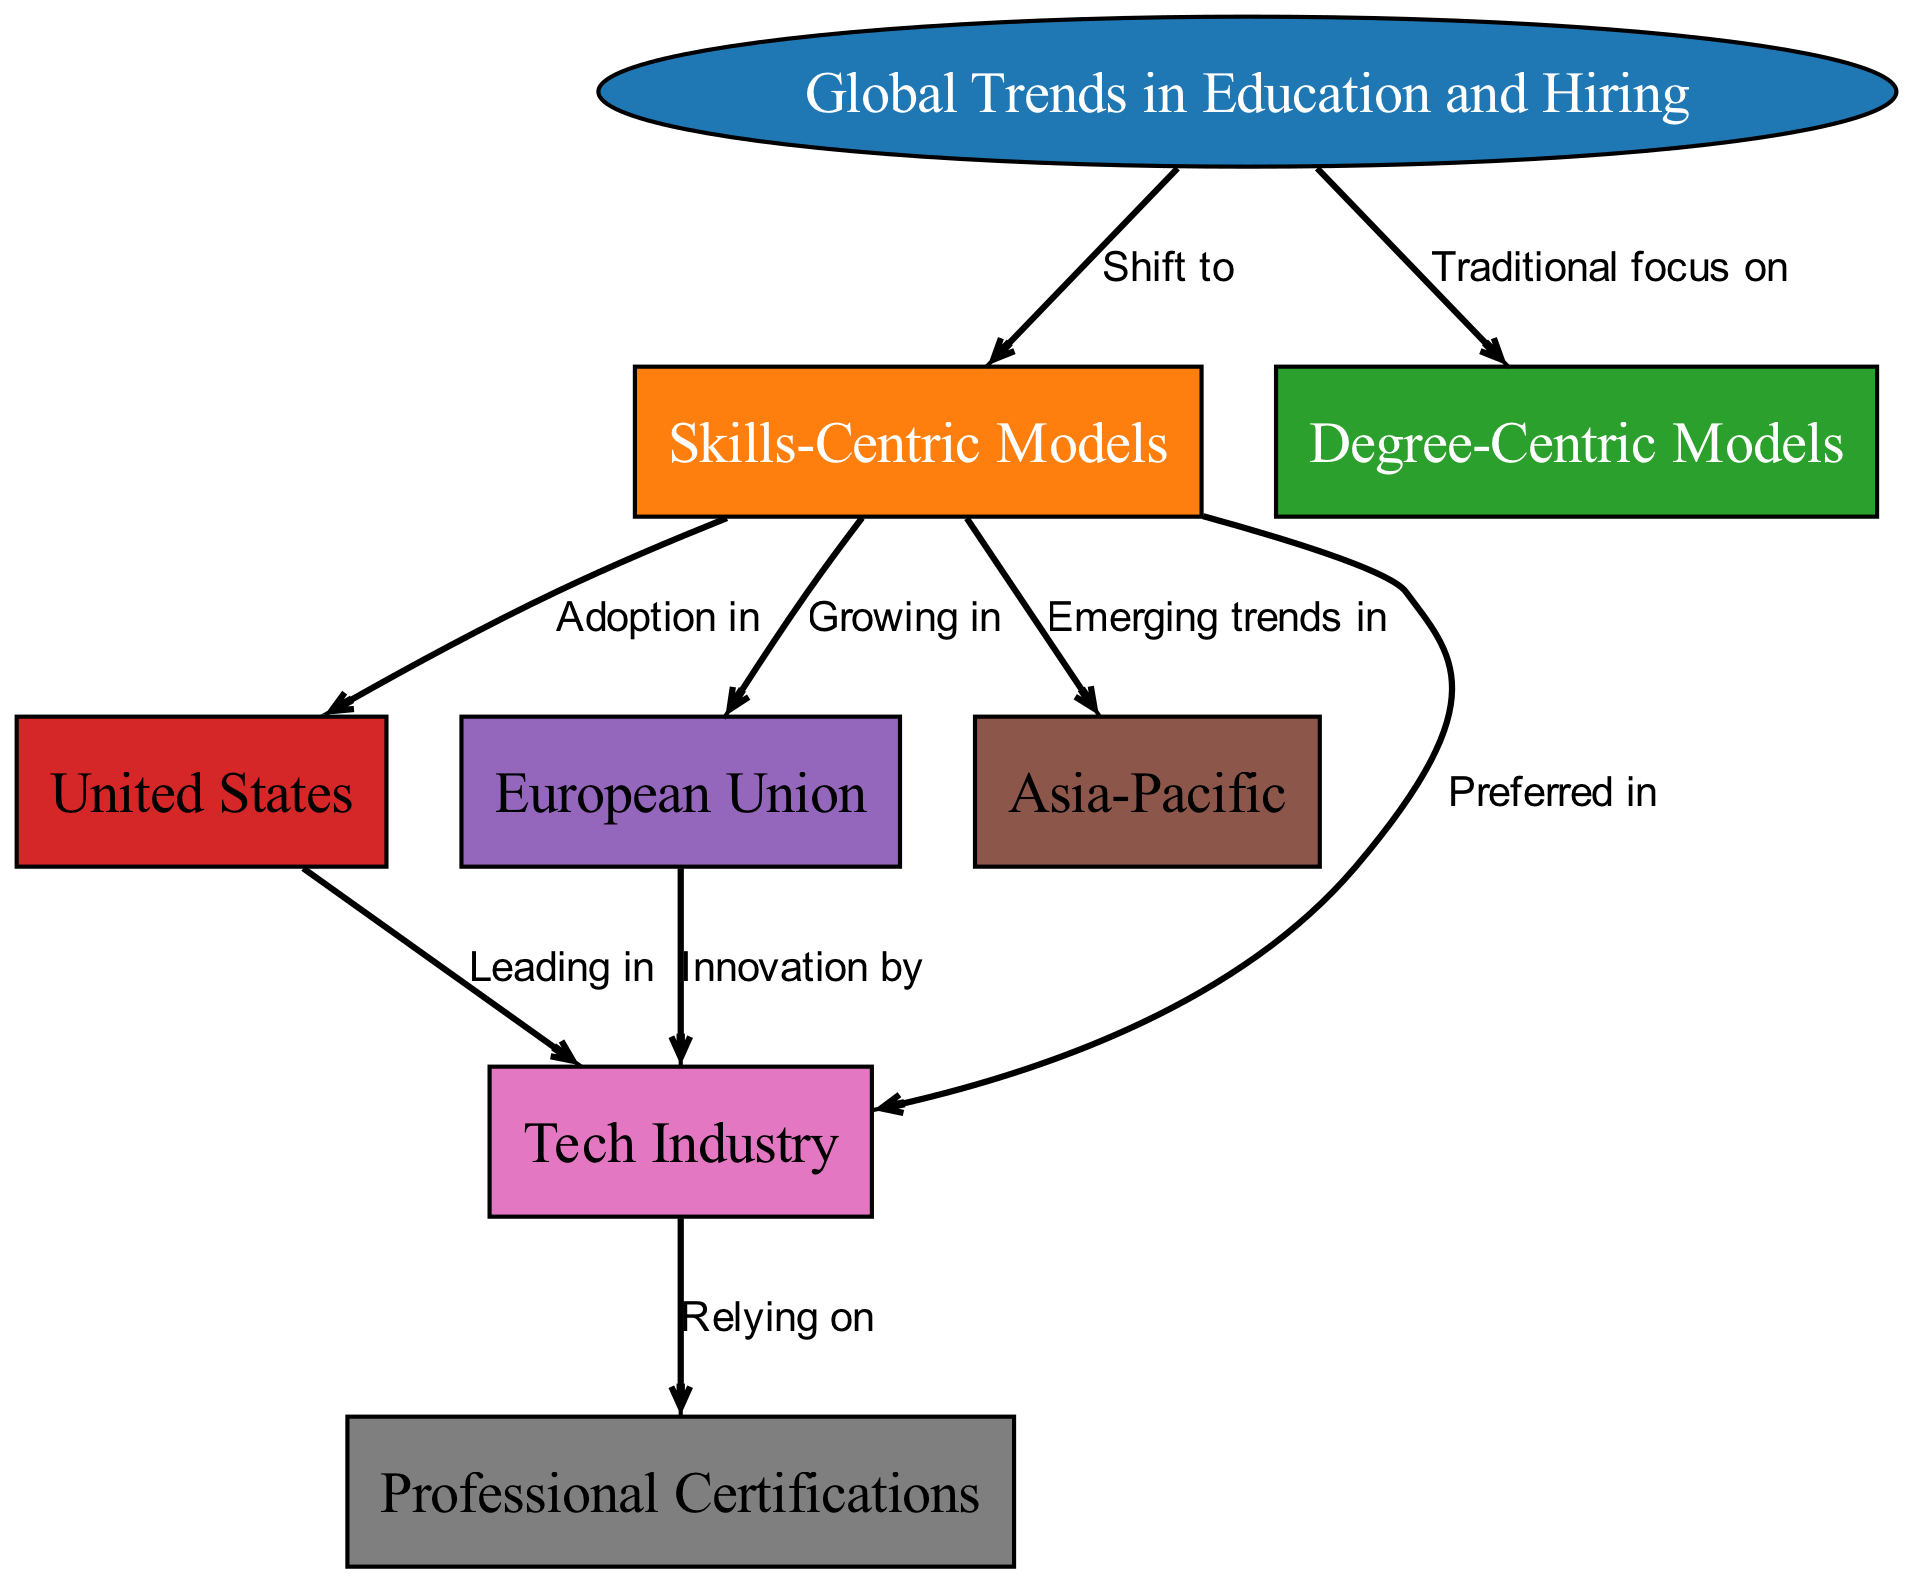What is the main focus of the diagram? The diagram centers around "Global Trends in Education and Hiring," which is indicated as the primary node. This node connects to both skills-centric and degree-centric models, highlighting the overarching theme of the diagram.
Answer: Global Trends in Education and Hiring How many nodes are in the diagram? By counting the six distinct nodes listed (including the primary one), we find that there are eight nodes total present in the diagram: Global Trends in Education and Hiring, Skills-Centric Models, Degree-Centric Models, United States, European Union, Asia-Pacific, Tech Industry, and Professional Certifications.
Answer: 8 Which region is leading in the tech industry according to the diagram? The arrows in the diagram point from "United States" to "Tech Industry," signifying that the diagram indicates the United States as the leading region in this sector based on the depicted relationships.
Answer: United States What type of model is preferred in the tech industry? The diagram indicates "Skills-Centric Models" as the preferred model in the tech industry, derived from the connection pointing from the skills-centric models node to the tech industry node.
Answer: Skills-Centric Models Which two regions are experiencing a shift towards skills-centric models? Both the United States and European Union are connected to "Skills-Centric Models" through arrows indicating their adoption of this model, representing their shift in hiring practices.
Answer: United States and European Union What industries rely on professional certifications? The diagram indicates that the "Tech Industry" relies on "Professional Certifications," as shown by the directed edge between these two nodes, defining their dependency as a key relationship within the diagram.
Answer: Tech Industry Which model is depicted as having a traditional focus? The diagram explicitly states "Degree-Centric Models" as having a traditional focus, indicated by the edge labeled as "Traditional focus on" directed towards this model node.
Answer: Degree-Centric Models How does the European Union contribute to the tech industry? The relationship from "European Union" to "Tech Industry," marked by "Innovation by," indicates that the European Union is contributing through innovation toward the growth and dynamism of the tech industry.
Answer: Innovation by What is one emerging trend in Asia-Pacific regarding models? The diagram indicates “Emerging trends in” with a connection pointing to "Skills-Centric Models," suggesting that this region is increasingly moving towards skills-based approaches in education and hiring processes.
Answer: Skills-Centric Models 